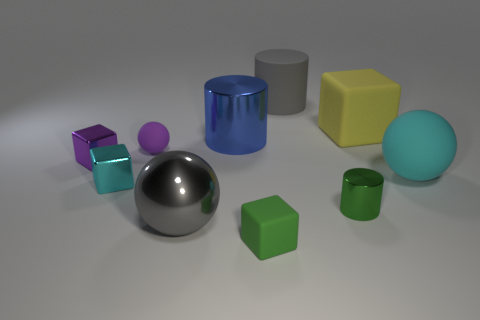The metal cube that is the same color as the large matte sphere is what size?
Offer a very short reply. Small. There is a big metal ball; is it the same color as the cylinder behind the big cube?
Your answer should be very brief. Yes. Is there a large rubber object that has the same shape as the purple metal object?
Ensure brevity in your answer.  Yes. Do the purple thing behind the small purple cube and the large matte object that is in front of the big yellow block have the same shape?
Offer a terse response. Yes. How many large shiny cylinders have the same color as the tiny metallic cylinder?
Make the answer very short. 0. What is the color of the matte thing that is the same shape as the blue metallic object?
Keep it short and to the point. Gray. How many green shiny cylinders are to the left of the tiny purple matte object behind the large cyan matte thing?
Give a very brief answer. 0. How many spheres are large blue objects or yellow rubber objects?
Your answer should be very brief. 0. Is there a big purple cylinder?
Make the answer very short. No. There is a gray thing that is the same shape as the green metal thing; what is its size?
Give a very brief answer. Large. 